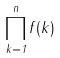Convert formula to latex. <formula><loc_0><loc_0><loc_500><loc_500>\prod _ { k = 1 } ^ { n } f ( k )</formula> 